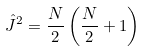<formula> <loc_0><loc_0><loc_500><loc_500>\hat { J } ^ { 2 } = \frac { N } { 2 } \left ( \frac { N } { 2 } + 1 \right )</formula> 